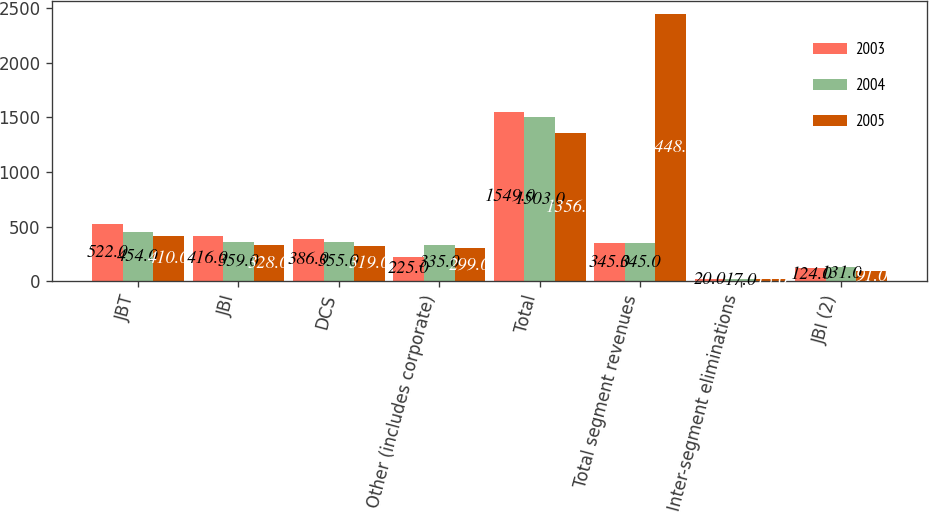Convert chart to OTSL. <chart><loc_0><loc_0><loc_500><loc_500><stacked_bar_chart><ecel><fcel>JBT<fcel>JBI<fcel>DCS<fcel>Other (includes corporate)<fcel>Total<fcel>Total segment revenues<fcel>Inter-segment eliminations<fcel>JBI (2)<nl><fcel>2003<fcel>522<fcel>416<fcel>386<fcel>225<fcel>1549<fcel>345<fcel>20<fcel>124<nl><fcel>2004<fcel>454<fcel>359<fcel>355<fcel>335<fcel>1503<fcel>345<fcel>17<fcel>131<nl><fcel>2005<fcel>410<fcel>328<fcel>319<fcel>299<fcel>1356<fcel>2448<fcel>15<fcel>91<nl></chart> 